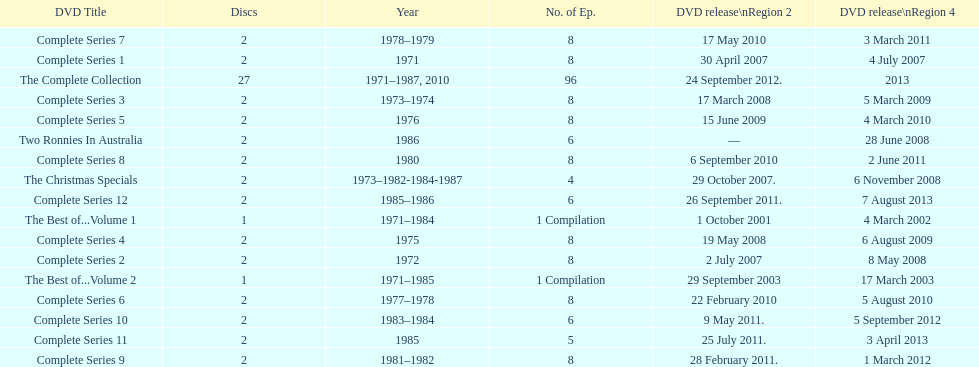What is the total of all dics listed in the table? 57. 